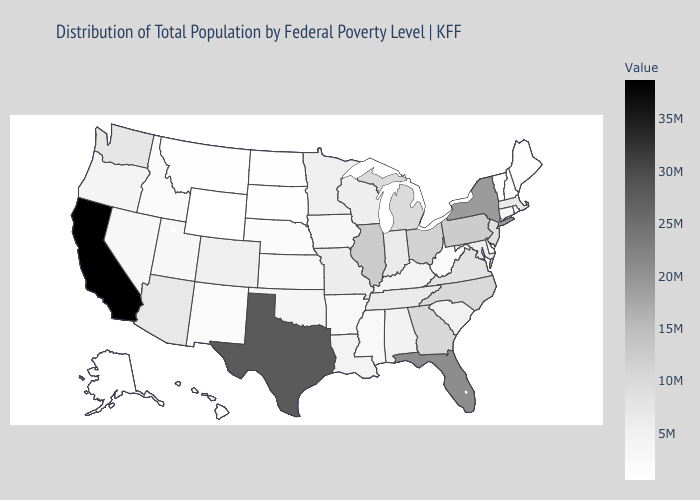Does Florida have a lower value than South Dakota?
Write a very short answer. No. Which states have the lowest value in the MidWest?
Concise answer only. North Dakota. Which states hav the highest value in the West?
Write a very short answer. California. Among the states that border Vermont , which have the lowest value?
Concise answer only. New Hampshire. 